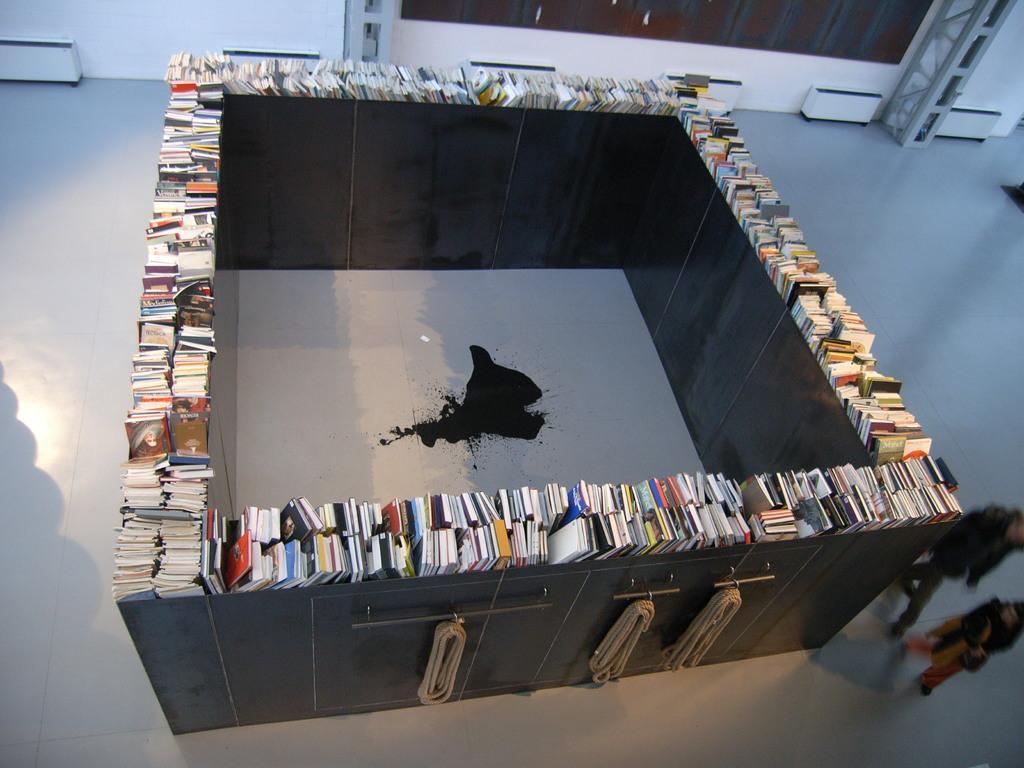In one or two sentences, can you explain what this image depicts? In this image we can see few books on the shelf and there are ropes to the rods of shelf, there are two person walking on the floor, in the background there is a window, iron pole and few white color objects near the wall. 